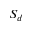<formula> <loc_0><loc_0><loc_500><loc_500>S _ { d }</formula> 